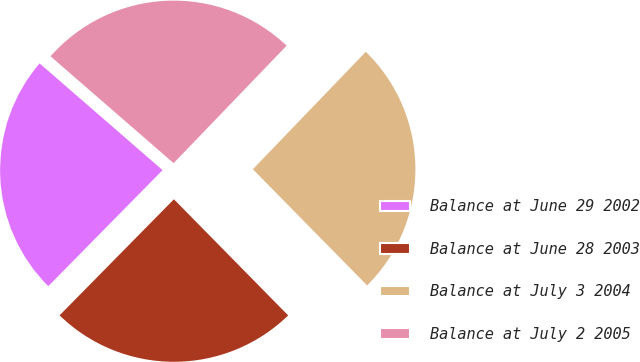<chart> <loc_0><loc_0><loc_500><loc_500><pie_chart><fcel>Balance at June 29 2002<fcel>Balance at June 28 2003<fcel>Balance at July 3 2004<fcel>Balance at July 2 2005<nl><fcel>24.0%<fcel>24.75%<fcel>25.44%<fcel>25.81%<nl></chart> 